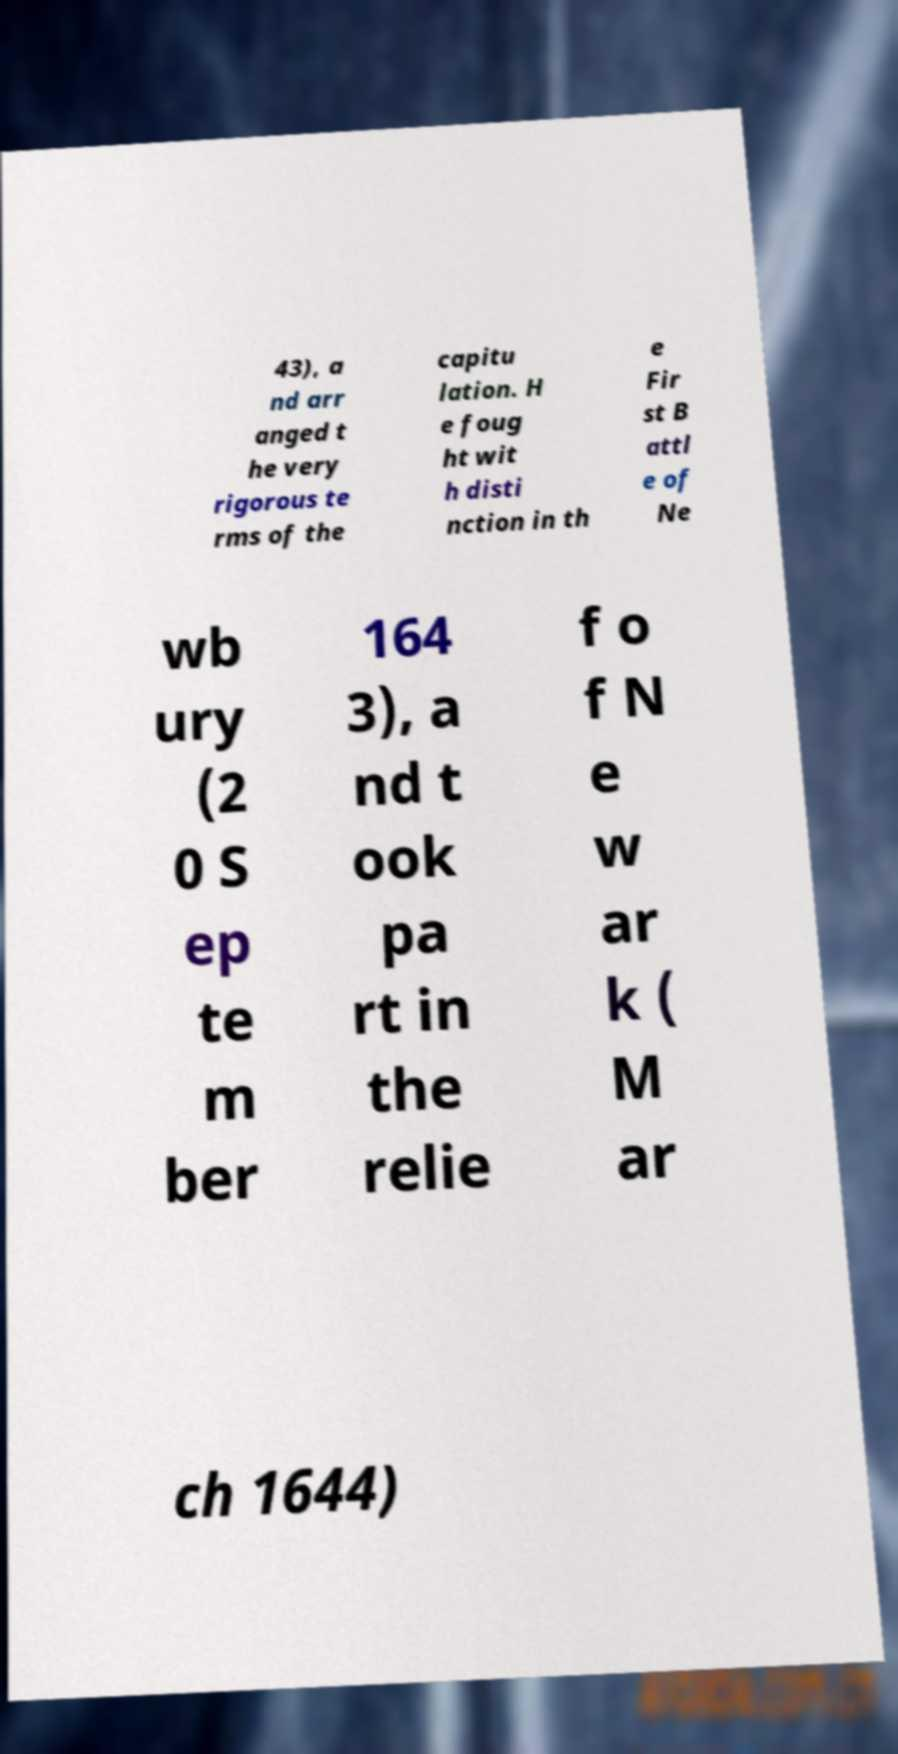Can you read and provide the text displayed in the image?This photo seems to have some interesting text. Can you extract and type it out for me? 43), a nd arr anged t he very rigorous te rms of the capitu lation. H e foug ht wit h disti nction in th e Fir st B attl e of Ne wb ury (2 0 S ep te m ber 164 3), a nd t ook pa rt in the relie f o f N e w ar k ( M ar ch 1644) 